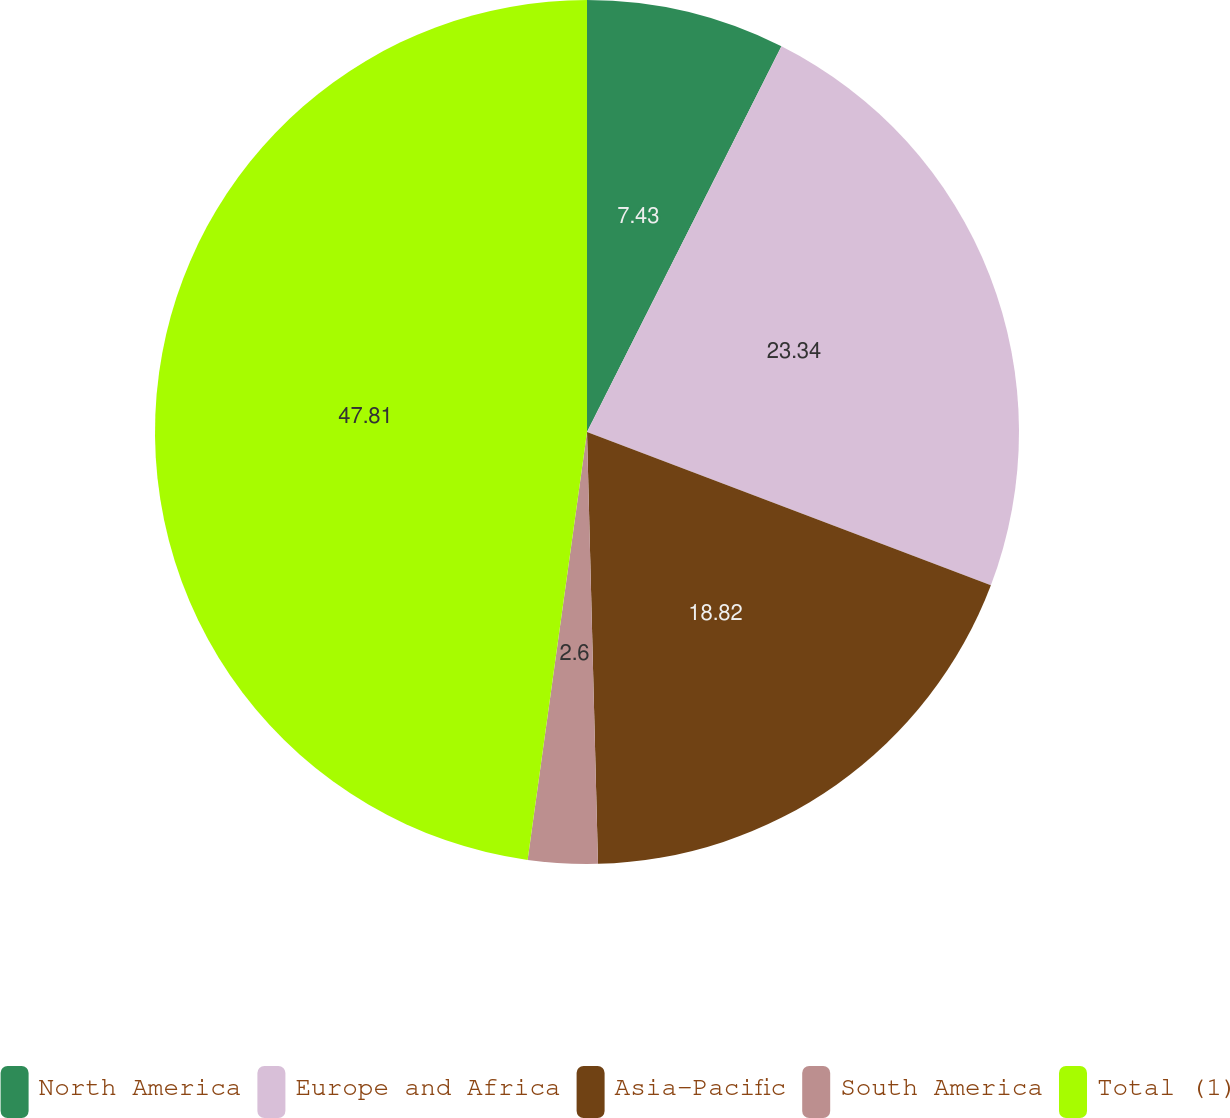Convert chart to OTSL. <chart><loc_0><loc_0><loc_500><loc_500><pie_chart><fcel>North America<fcel>Europe and Africa<fcel>Asia-Pacific<fcel>South America<fcel>Total (1)<nl><fcel>7.43%<fcel>23.34%<fcel>18.82%<fcel>2.6%<fcel>47.8%<nl></chart> 